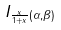<formula> <loc_0><loc_0><loc_500><loc_500>I _ { \frac { x } { 1 + x } ( \alpha , \beta ) }</formula> 